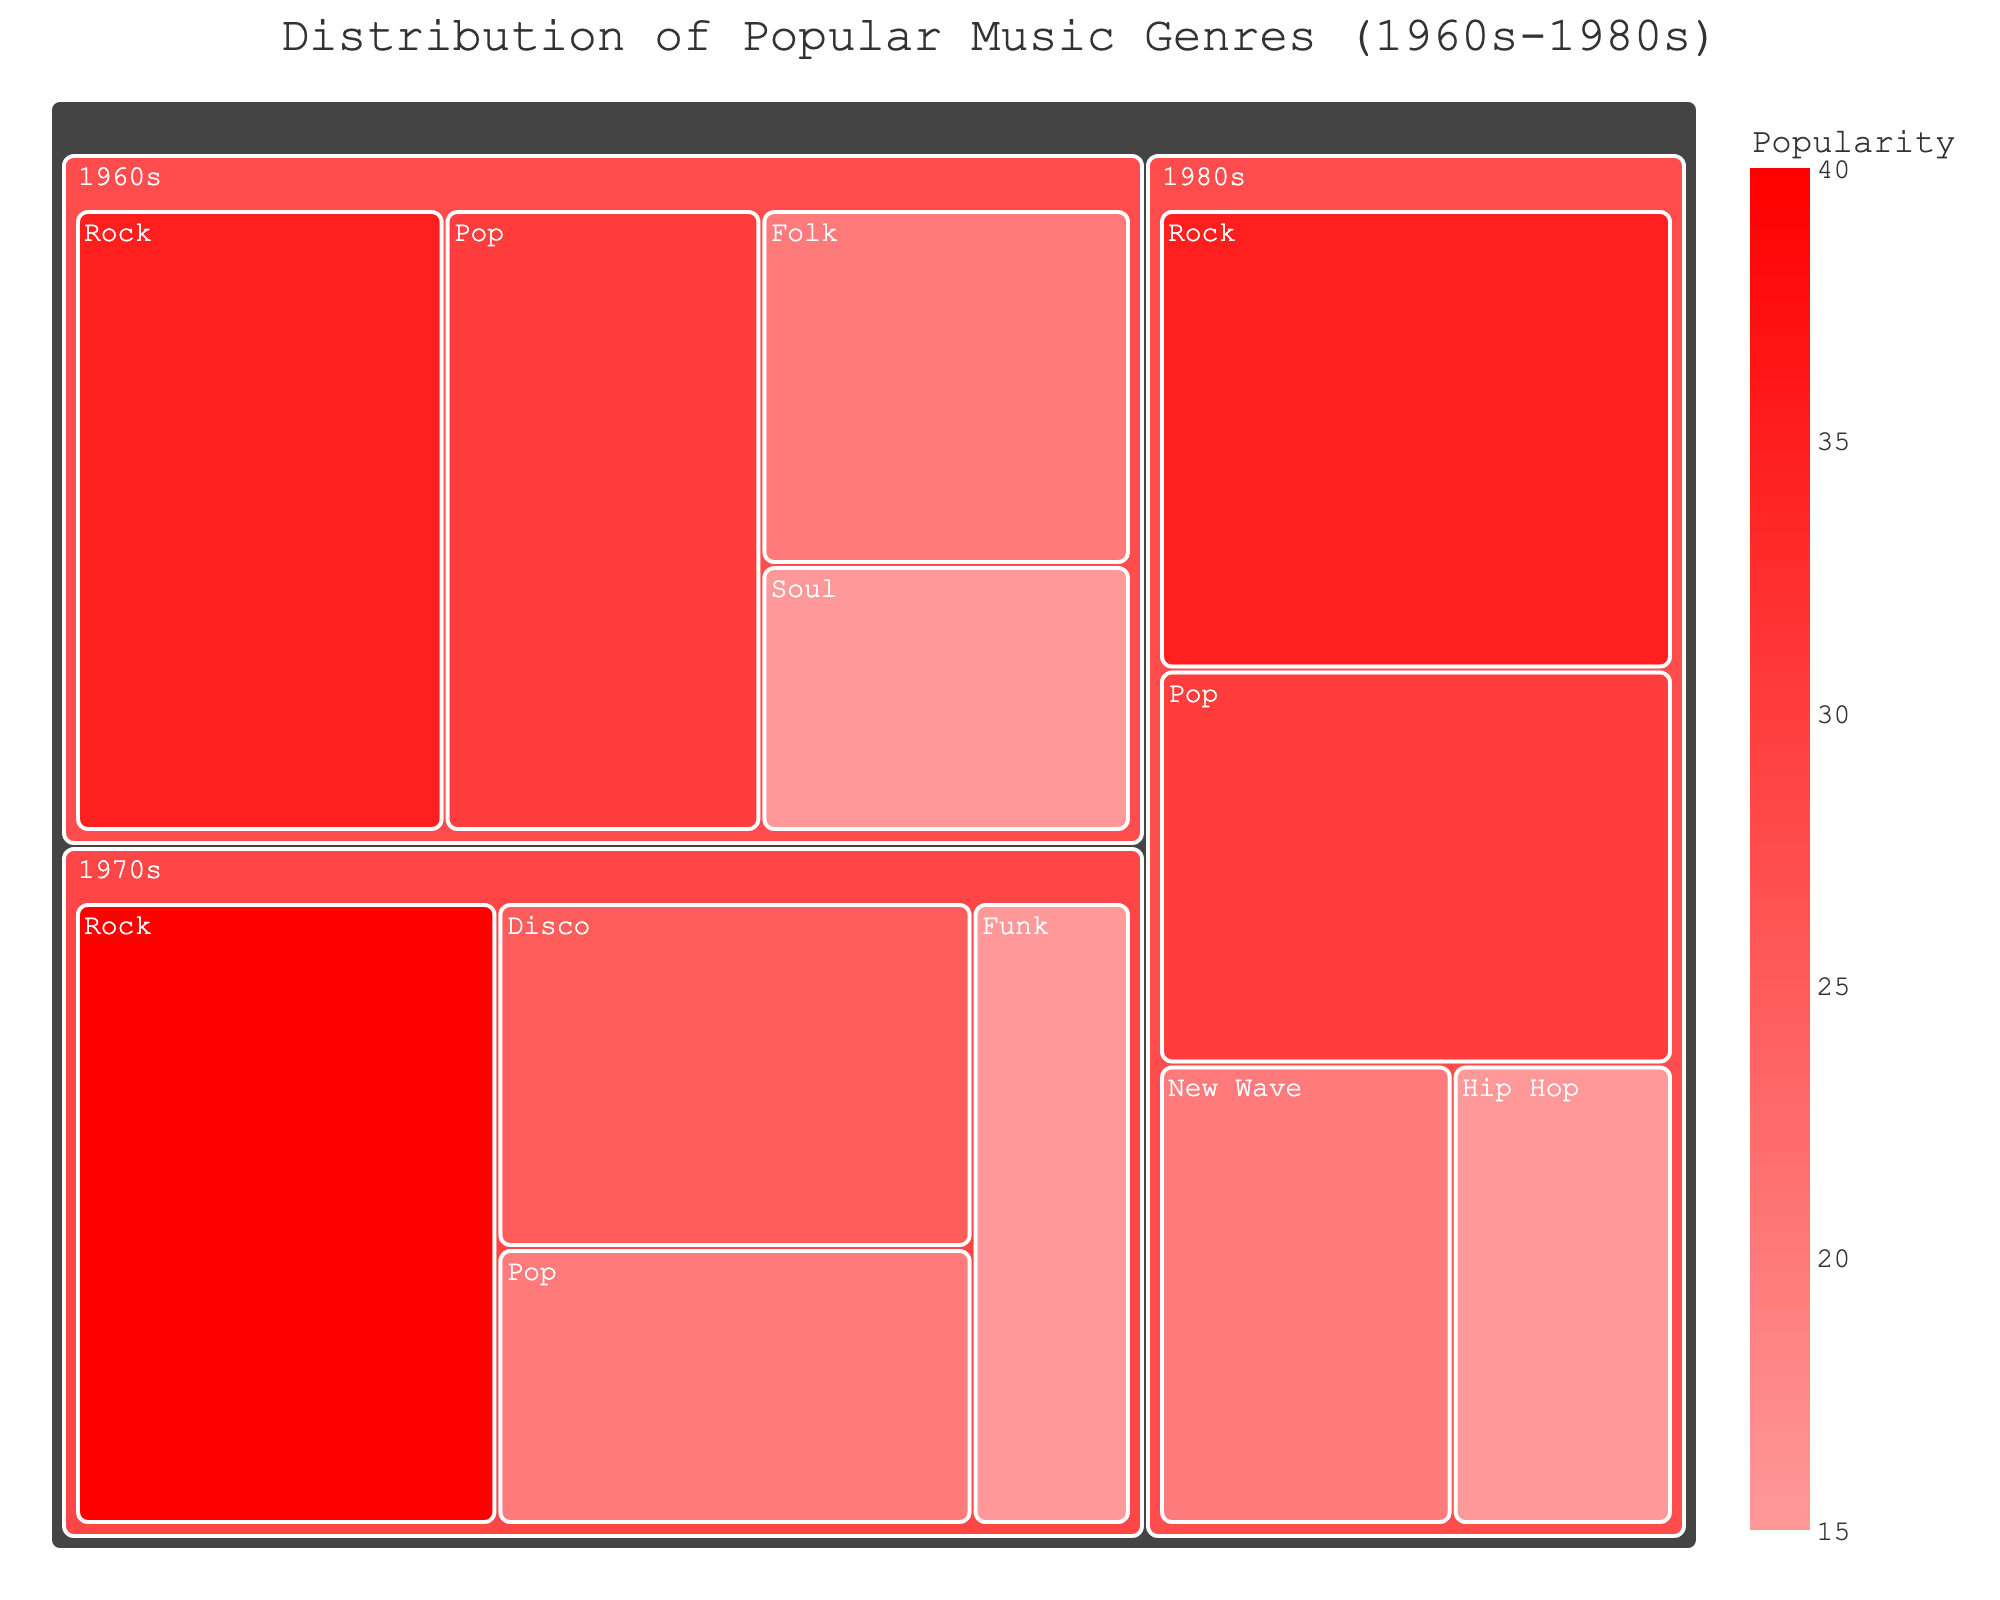what's the most popular music genre in the 1960s? The largest segment in the 1960s section of the treemap represents Rock with a popularity value of 35.
Answer: Rock Which decade has the highest representation of Rock music? Compare the sizes of Rock segments across the 1960s, 1970s, and 1980s. The 1970s have the highest value for Rock at 40.
Answer: 1970s What are the two least popular genres in the 1980s? Identify the two smallest segments within the 1980s section. They are New Wave at 20 and Hip Hop at 15.
Answer: New Wave and Hip Hop By how much did the popularity of Rock music change from the 1960s to the 1980s? Find the difference between the popularity of Rock in the 1960s (35) and the 1980s (35).
Answer: 0 What's the total popularity percentage of Pop music across the decades? Sum up the popularity values of Pop music in the 1960s (30), 1970s (20), and 1980s (30). (30 + 20 + 30) = 80.
Answer: 80 Which genre had the same level of popularity in two different decades? Scan the treemap to find any genre appearing with the same popularity in two distinct decades. Pop has a popularity of 30 in both the 1960s and 1980s.
Answer: Pop What's the trend of Soul music from the 1960s to 70s and 80s? The treemap only records Soul in the 1960s with a popularity of 15, indicating that Soul was not prominent in the 1970s and 1980s.
Answer: Declined Which decade has the most balanced distribution of musical genres? Evaluate the diversity and even distribution of genre segments per decade. The 1980s show a more balanced spread among Rock, Pop, New Wave, and Hip Hop compared to other decades.
Answer: 1980s 